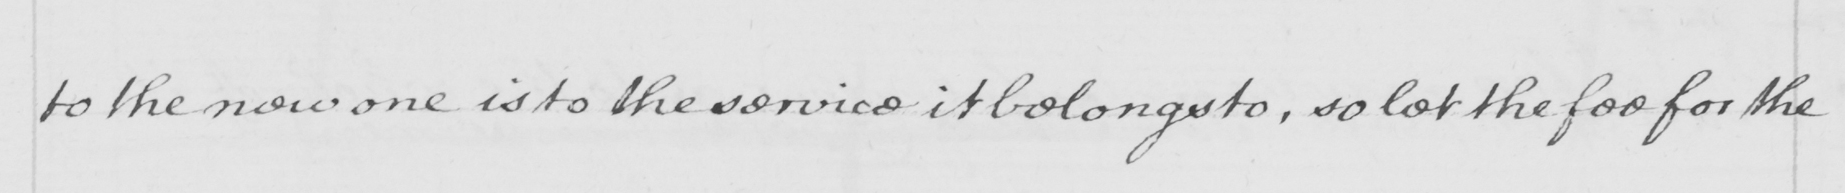What text is written in this handwritten line? to the new one is to the service it belongs to , so let the fee for the 